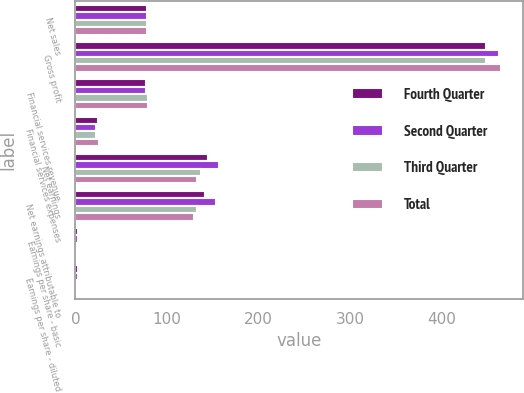Convert chart to OTSL. <chart><loc_0><loc_0><loc_500><loc_500><stacked_bar_chart><ecel><fcel>Net sales<fcel>Gross profit<fcel>Financial services revenue<fcel>Financial services expenses<fcel>Net earnings<fcel>Net earnings attributable to<fcel>Earnings per share - basic<fcel>Earnings per share - diluted<nl><fcel>Fourth Quarter<fcel>78.35<fcel>448.3<fcel>76.8<fcel>24.3<fcel>145.1<fcel>141.6<fcel>2.45<fcel>2.39<nl><fcel>Second Quarter<fcel>78.35<fcel>463.2<fcel>77.7<fcel>23.1<fcel>156.8<fcel>153.2<fcel>2.65<fcel>2.6<nl><fcel>Third Quarter<fcel>78.35<fcel>448.8<fcel>79<fcel>23<fcel>137.1<fcel>133.4<fcel>2.33<fcel>2.29<nl><fcel>Total<fcel>78.35<fcel>465.6<fcel>79.9<fcel>25.5<fcel>133.2<fcel>129.5<fcel>2.28<fcel>2.24<nl></chart> 